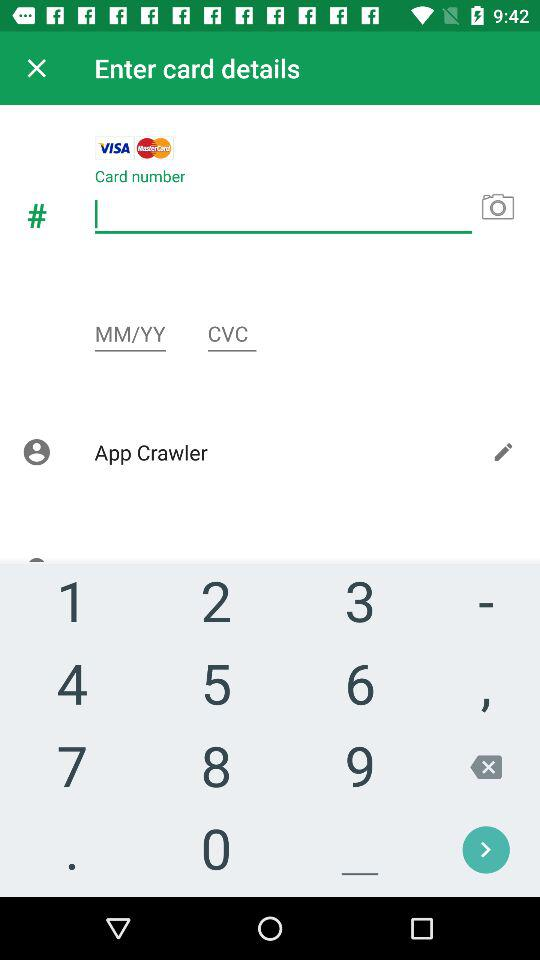How many digits are in the CVC?
Answer the question using a single word or phrase. 3 